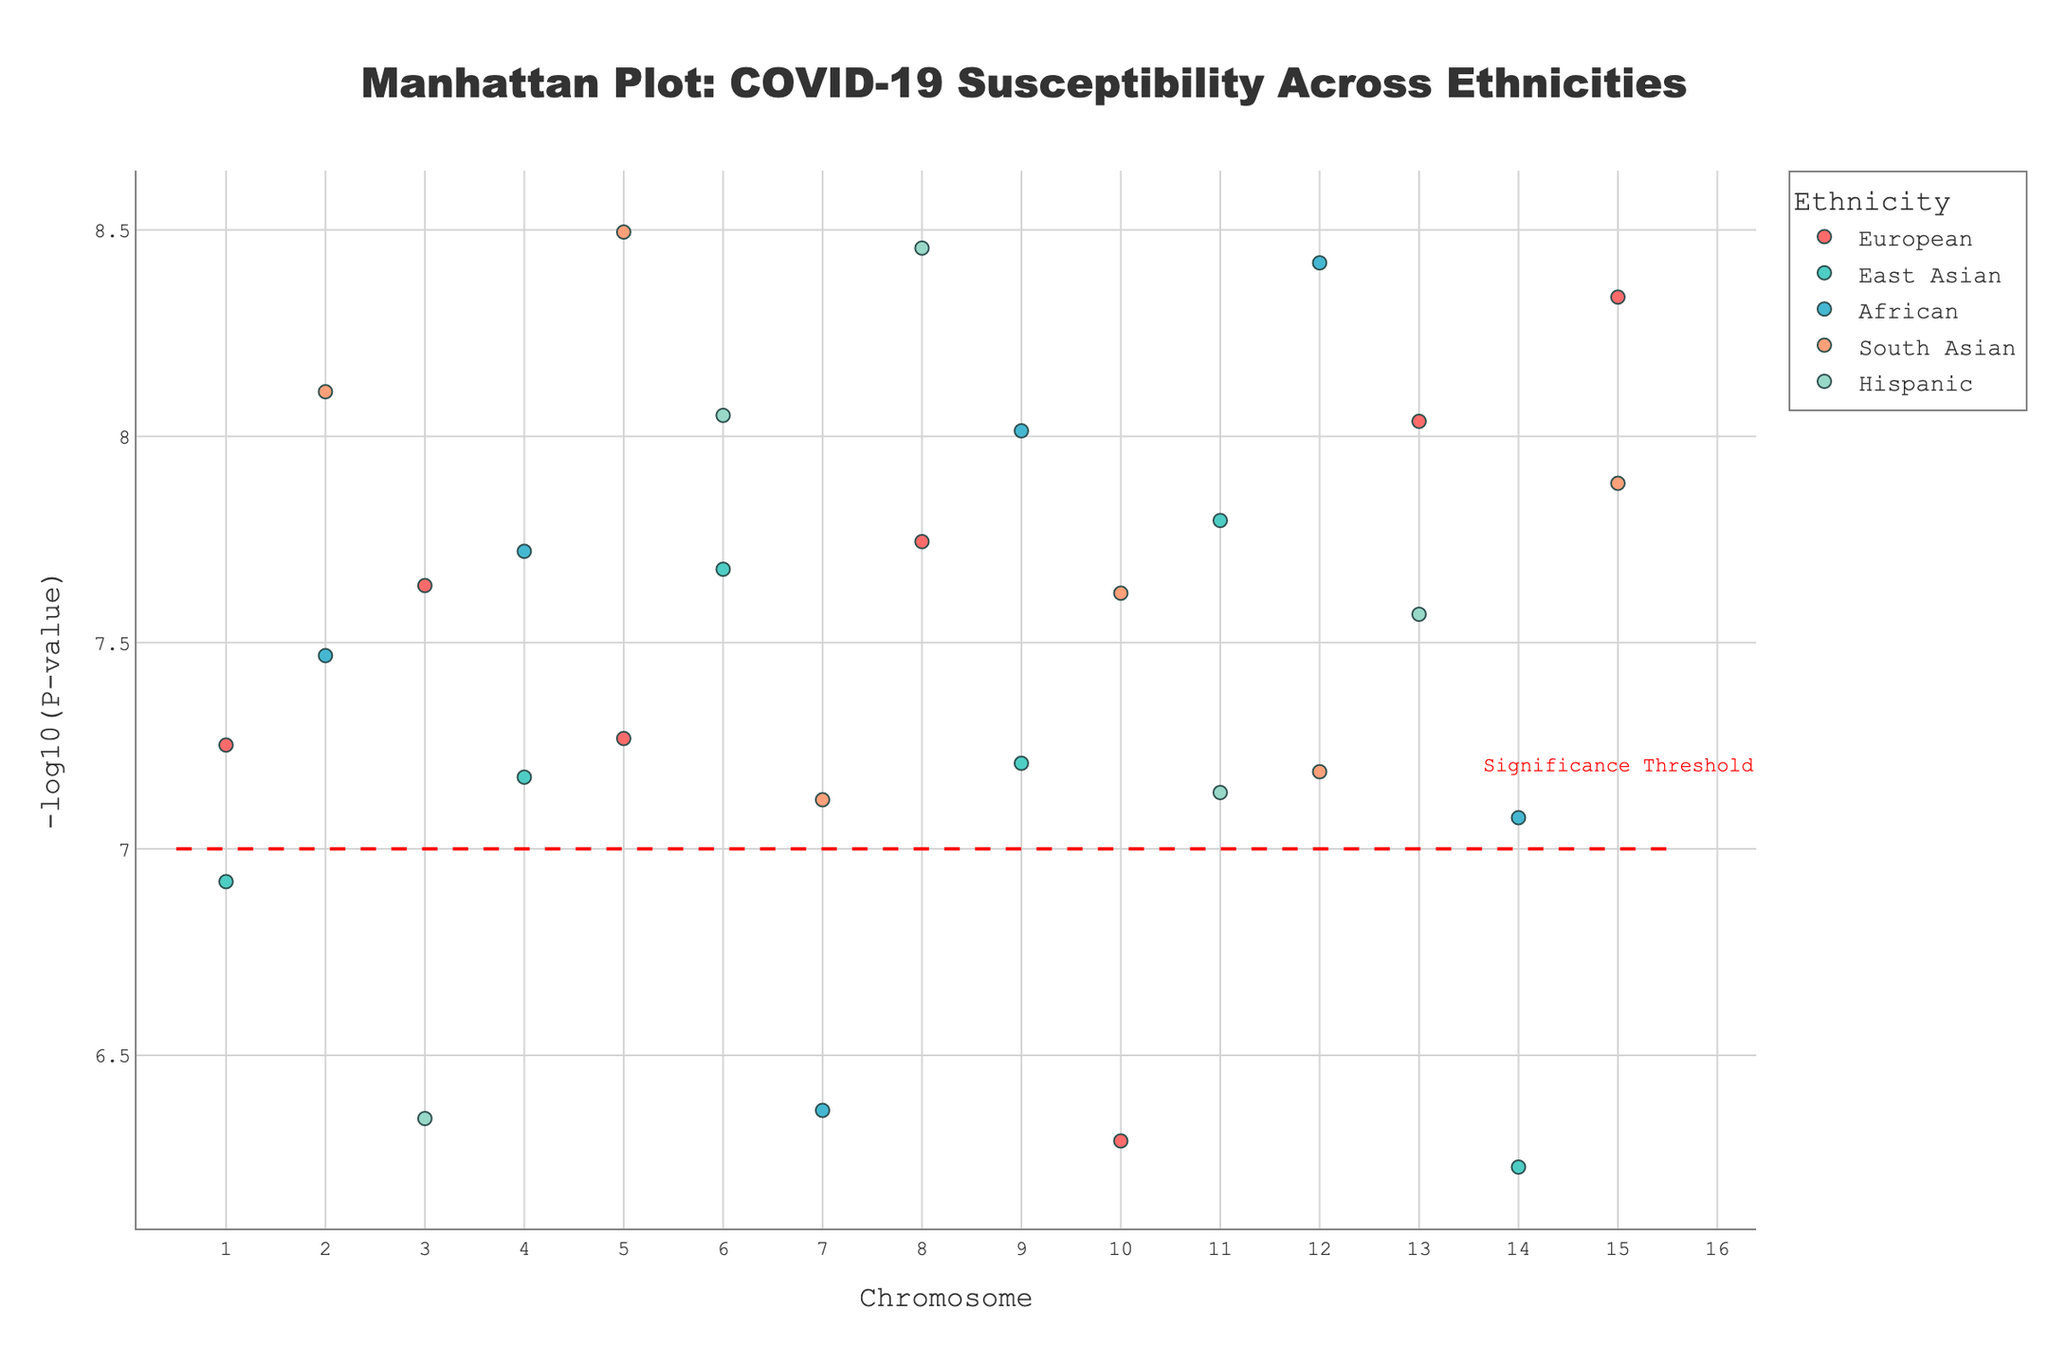What is the title of the plot? The title is positioned at the top of the plot and is typically the most prominent text. It summarizes what the plot represents.
Answer: Manhattan Plot: COVID-19 Susceptibility Across Ethnicities What are the x-axis and y-axis labels? The labels for the axes are usually provided to indicate what each axis represents. In this plot, the x-axis represents Chromosome, and the y-axis represents -log10(P-value).
Answer: Chromosome; -log10(P-value) Which ethnicity has the most significant SNP association based on the smallest p-value? The SNP with the smallest p-value will have the highest -log10(P-value). By examining the plot, the highest point indicates the most significant association. For Hispanic ethnicity, the highest point is rs67890 on Chromosome 8.
Answer: Hispanic How many ethnicities have SNPs with -log10(P-value) greater than 7? Look for the SNPs that lie above the red significance threshold line at y=7. Count the number of unique ethnicities represented by these points.
Answer: 5 Which chromosome shows the most variability in -log10(P-value) for SNPs across different ethnicities? Variability can be interpreted as the spread of y-values (-log10(P-value)). Chromosome 6 shows a broad range of values from multiple ethnicities.
Answer: Chromosome 6 Which ethnicity has the SNP with the highest -log10(P-value) and what is its p-value? The highest y-value corresponds to the SNP with the most significant p-value (smallest). Locate the highest point and identify its ethnicity and corresponding p-value. For Hispanic ethnicity, the top SNP is rs67890 with a p-value of 3.5e-09.
Answer: Hispanic; 3.5e-09 Compare the number of significant SNPs (-log10(P-value) > 7) for European and South Asian ethnicities. Which has more? Count the SNPs with -log10(P-value) greater than 7 for both European and South Asian ethnicities. Compare the counts. European ethnicity has 3 such SNPs, while South Asian has 4.
Answer: South Asian What is the range of -log10(P-value) for SNPs on Chromosome 2? Identify the minimum and maximum -log10(P-value) on Chromosome 2 by looking at the data points along this chromosome. The values range from approximately 7.11 to 8.11.
Answer: Approximately 7.11 to 8.11 Identify any SNPs and their associated ethnicity with a -log10(P-value) near 8. Look for points near y = 8 and note their respective SNPs and ethnicities. For example, rs67890 for Hispanic on Chromosome 8 is near 8.
Answer: rs67890, Hispanic 